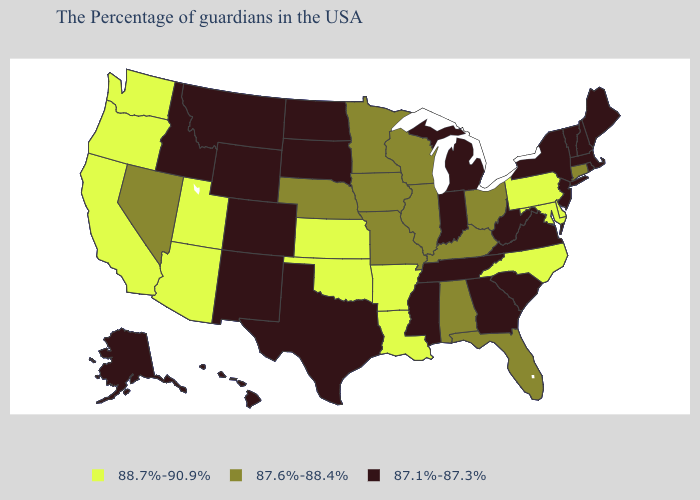What is the value of Nevada?
Give a very brief answer. 87.6%-88.4%. What is the highest value in the Northeast ?
Keep it brief. 88.7%-90.9%. Among the states that border Pennsylvania , which have the lowest value?
Be succinct. New York, New Jersey, West Virginia. Among the states that border West Virginia , does Pennsylvania have the highest value?
Give a very brief answer. Yes. Name the states that have a value in the range 87.1%-87.3%?
Write a very short answer. Maine, Massachusetts, Rhode Island, New Hampshire, Vermont, New York, New Jersey, Virginia, South Carolina, West Virginia, Georgia, Michigan, Indiana, Tennessee, Mississippi, Texas, South Dakota, North Dakota, Wyoming, Colorado, New Mexico, Montana, Idaho, Alaska, Hawaii. Which states have the lowest value in the USA?
Write a very short answer. Maine, Massachusetts, Rhode Island, New Hampshire, Vermont, New York, New Jersey, Virginia, South Carolina, West Virginia, Georgia, Michigan, Indiana, Tennessee, Mississippi, Texas, South Dakota, North Dakota, Wyoming, Colorado, New Mexico, Montana, Idaho, Alaska, Hawaii. What is the value of Delaware?
Quick response, please. 88.7%-90.9%. Name the states that have a value in the range 87.6%-88.4%?
Keep it brief. Connecticut, Ohio, Florida, Kentucky, Alabama, Wisconsin, Illinois, Missouri, Minnesota, Iowa, Nebraska, Nevada. How many symbols are there in the legend?
Answer briefly. 3. What is the value of Connecticut?
Be succinct. 87.6%-88.4%. What is the value of Idaho?
Answer briefly. 87.1%-87.3%. Name the states that have a value in the range 87.1%-87.3%?
Answer briefly. Maine, Massachusetts, Rhode Island, New Hampshire, Vermont, New York, New Jersey, Virginia, South Carolina, West Virginia, Georgia, Michigan, Indiana, Tennessee, Mississippi, Texas, South Dakota, North Dakota, Wyoming, Colorado, New Mexico, Montana, Idaho, Alaska, Hawaii. Does Indiana have the lowest value in the MidWest?
Quick response, please. Yes. Is the legend a continuous bar?
Concise answer only. No. 